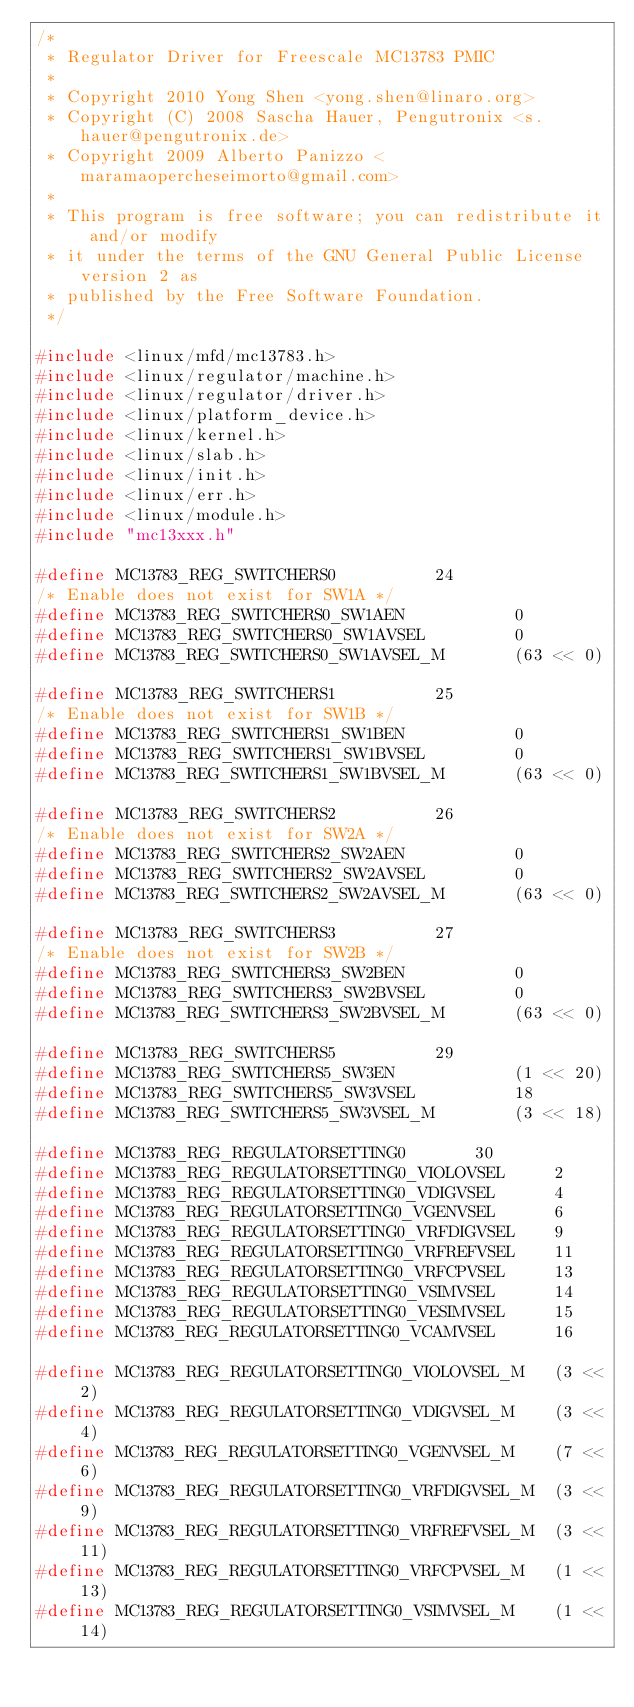<code> <loc_0><loc_0><loc_500><loc_500><_C_>/*
 * Regulator Driver for Freescale MC13783 PMIC
 *
 * Copyright 2010 Yong Shen <yong.shen@linaro.org>
 * Copyright (C) 2008 Sascha Hauer, Pengutronix <s.hauer@pengutronix.de>
 * Copyright 2009 Alberto Panizzo <maramaopercheseimorto@gmail.com>
 *
 * This program is free software; you can redistribute it and/or modify
 * it under the terms of the GNU General Public License version 2 as
 * published by the Free Software Foundation.
 */

#include <linux/mfd/mc13783.h>
#include <linux/regulator/machine.h>
#include <linux/regulator/driver.h>
#include <linux/platform_device.h>
#include <linux/kernel.h>
#include <linux/slab.h>
#include <linux/init.h>
#include <linux/err.h>
#include <linux/module.h>
#include "mc13xxx.h"

#define MC13783_REG_SWITCHERS0			24
/* Enable does not exist for SW1A */
#define MC13783_REG_SWITCHERS0_SW1AEN			0
#define MC13783_REG_SWITCHERS0_SW1AVSEL			0
#define MC13783_REG_SWITCHERS0_SW1AVSEL_M		(63 << 0)

#define MC13783_REG_SWITCHERS1			25
/* Enable does not exist for SW1B */
#define MC13783_REG_SWITCHERS1_SW1BEN			0
#define MC13783_REG_SWITCHERS1_SW1BVSEL			0
#define MC13783_REG_SWITCHERS1_SW1BVSEL_M		(63 << 0)

#define MC13783_REG_SWITCHERS2			26
/* Enable does not exist for SW2A */
#define MC13783_REG_SWITCHERS2_SW2AEN			0
#define MC13783_REG_SWITCHERS2_SW2AVSEL			0
#define MC13783_REG_SWITCHERS2_SW2AVSEL_M		(63 << 0)

#define MC13783_REG_SWITCHERS3			27
/* Enable does not exist for SW2B */
#define MC13783_REG_SWITCHERS3_SW2BEN			0
#define MC13783_REG_SWITCHERS3_SW2BVSEL			0
#define MC13783_REG_SWITCHERS3_SW2BVSEL_M		(63 << 0)

#define MC13783_REG_SWITCHERS5			29
#define MC13783_REG_SWITCHERS5_SW3EN			(1 << 20)
#define MC13783_REG_SWITCHERS5_SW3VSEL			18
#define MC13783_REG_SWITCHERS5_SW3VSEL_M		(3 << 18)

#define MC13783_REG_REGULATORSETTING0		30
#define MC13783_REG_REGULATORSETTING0_VIOLOVSEL		2
#define MC13783_REG_REGULATORSETTING0_VDIGVSEL		4
#define MC13783_REG_REGULATORSETTING0_VGENVSEL		6
#define MC13783_REG_REGULATORSETTING0_VRFDIGVSEL	9
#define MC13783_REG_REGULATORSETTING0_VRFREFVSEL	11
#define MC13783_REG_REGULATORSETTING0_VRFCPVSEL		13
#define MC13783_REG_REGULATORSETTING0_VSIMVSEL		14
#define MC13783_REG_REGULATORSETTING0_VESIMVSEL		15
#define MC13783_REG_REGULATORSETTING0_VCAMVSEL		16

#define MC13783_REG_REGULATORSETTING0_VIOLOVSEL_M	(3 << 2)
#define MC13783_REG_REGULATORSETTING0_VDIGVSEL_M	(3 << 4)
#define MC13783_REG_REGULATORSETTING0_VGENVSEL_M	(7 << 6)
#define MC13783_REG_REGULATORSETTING0_VRFDIGVSEL_M	(3 << 9)
#define MC13783_REG_REGULATORSETTING0_VRFREFVSEL_M	(3 << 11)
#define MC13783_REG_REGULATORSETTING0_VRFCPVSEL_M	(1 << 13)
#define MC13783_REG_REGULATORSETTING0_VSIMVSEL_M	(1 << 14)</code> 